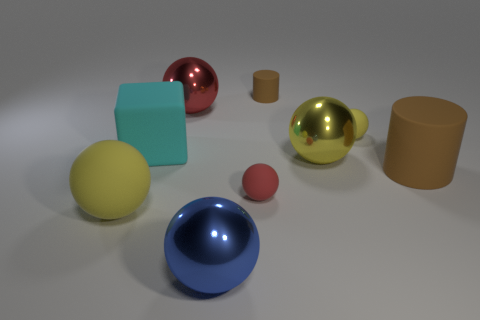What number of small green balls are there?
Your response must be concise. 0. There is a small object that is in front of the cyan rubber block; what is its material?
Make the answer very short. Rubber. There is a blue object; are there any large yellow matte things in front of it?
Give a very brief answer. No. Do the red shiny object and the cyan matte thing have the same size?
Your response must be concise. Yes. How many other large things are the same material as the big cyan object?
Your response must be concise. 2. There is a rubber block in front of the rubber cylinder behind the large block; what is its size?
Provide a short and direct response. Large. There is a large thing that is both in front of the cyan block and to the left of the large blue sphere; what is its color?
Offer a very short reply. Yellow. Does the big cyan rubber thing have the same shape as the tiny yellow thing?
Make the answer very short. No. There is a matte object that is the same color as the small matte cylinder; what is its size?
Your answer should be very brief. Large. What is the shape of the shiny thing that is on the left side of the metal object that is in front of the yellow metallic thing?
Your answer should be compact. Sphere. 